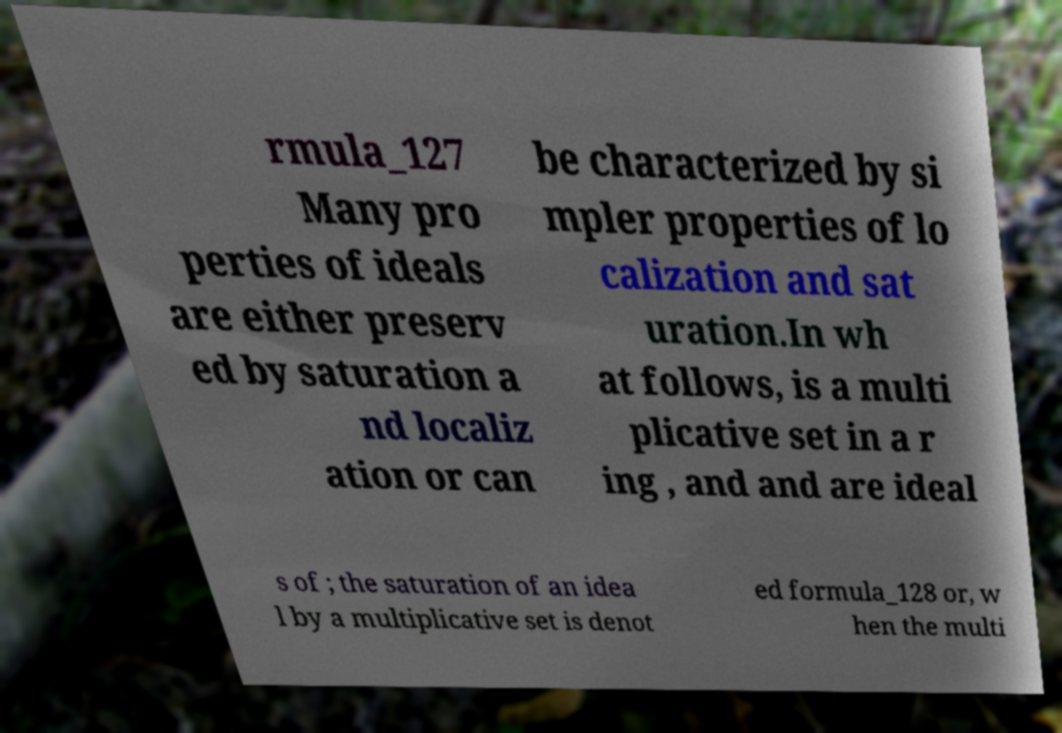Please read and relay the text visible in this image. What does it say? rmula_127 Many pro perties of ideals are either preserv ed by saturation a nd localiz ation or can be characterized by si mpler properties of lo calization and sat uration.In wh at follows, is a multi plicative set in a r ing , and and are ideal s of ; the saturation of an idea l by a multiplicative set is denot ed formula_128 or, w hen the multi 